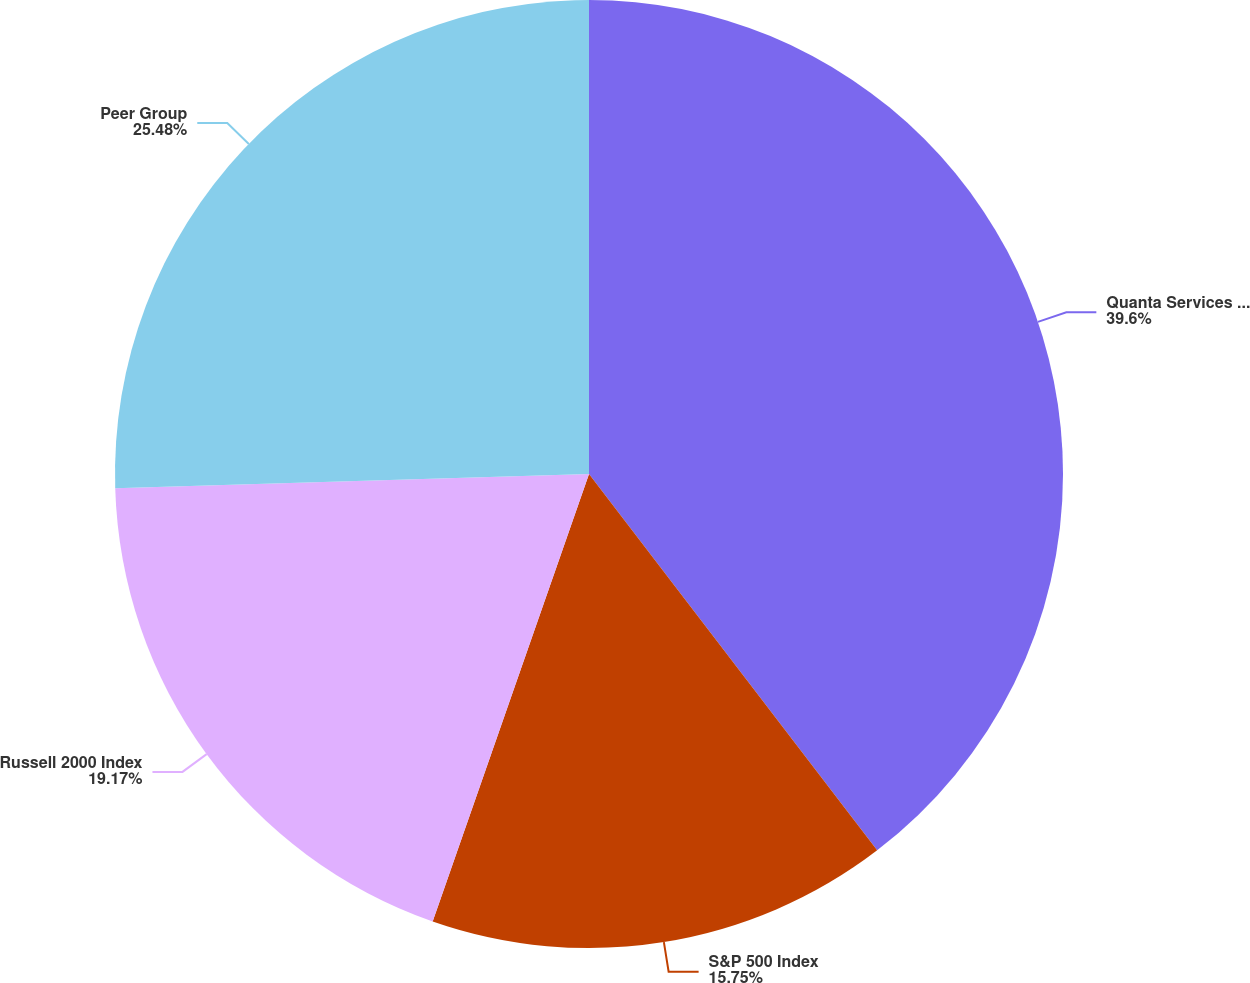Convert chart. <chart><loc_0><loc_0><loc_500><loc_500><pie_chart><fcel>Quanta Services Inc<fcel>S&P 500 Index<fcel>Russell 2000 Index<fcel>Peer Group<nl><fcel>39.6%<fcel>15.75%<fcel>19.17%<fcel>25.48%<nl></chart> 